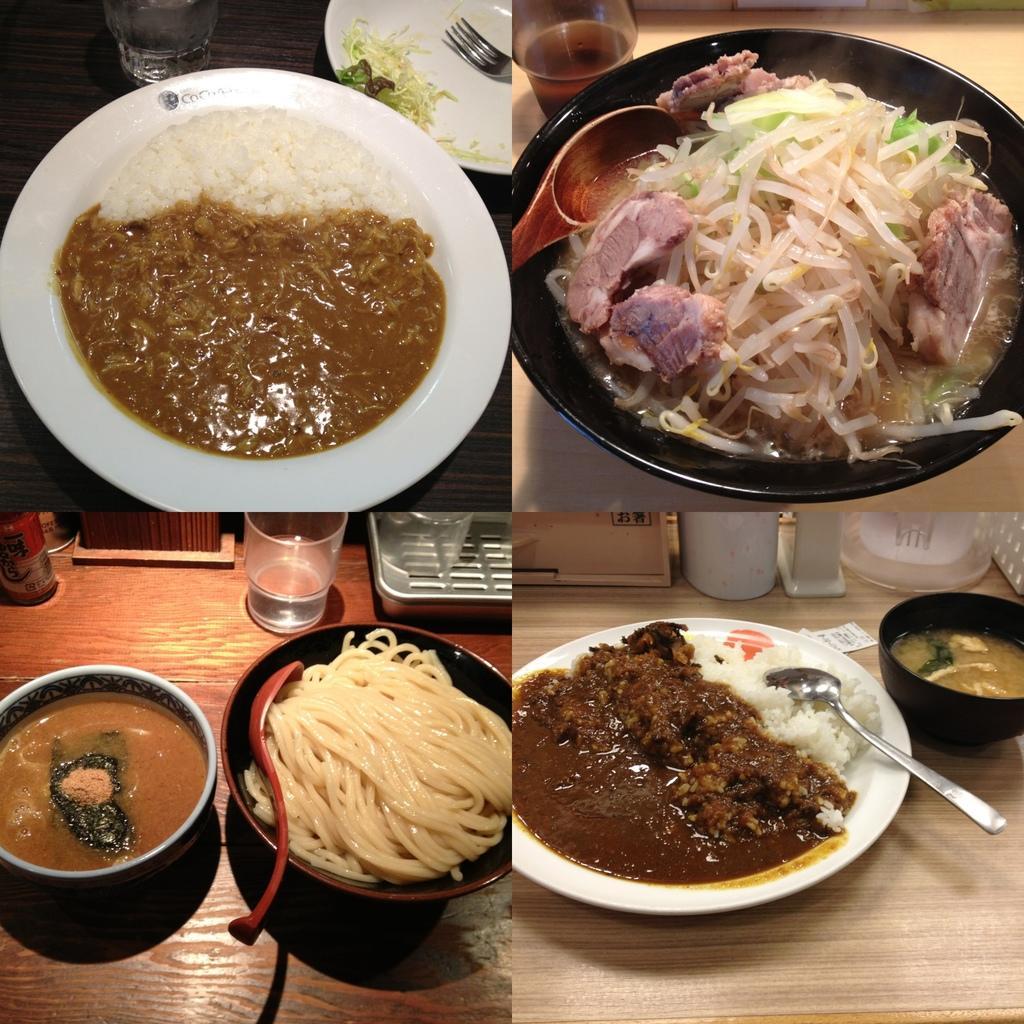Please provide a concise description of this image. In this picture we can see the college photographs of food in the white color plate which is placed on the wooden table top. 